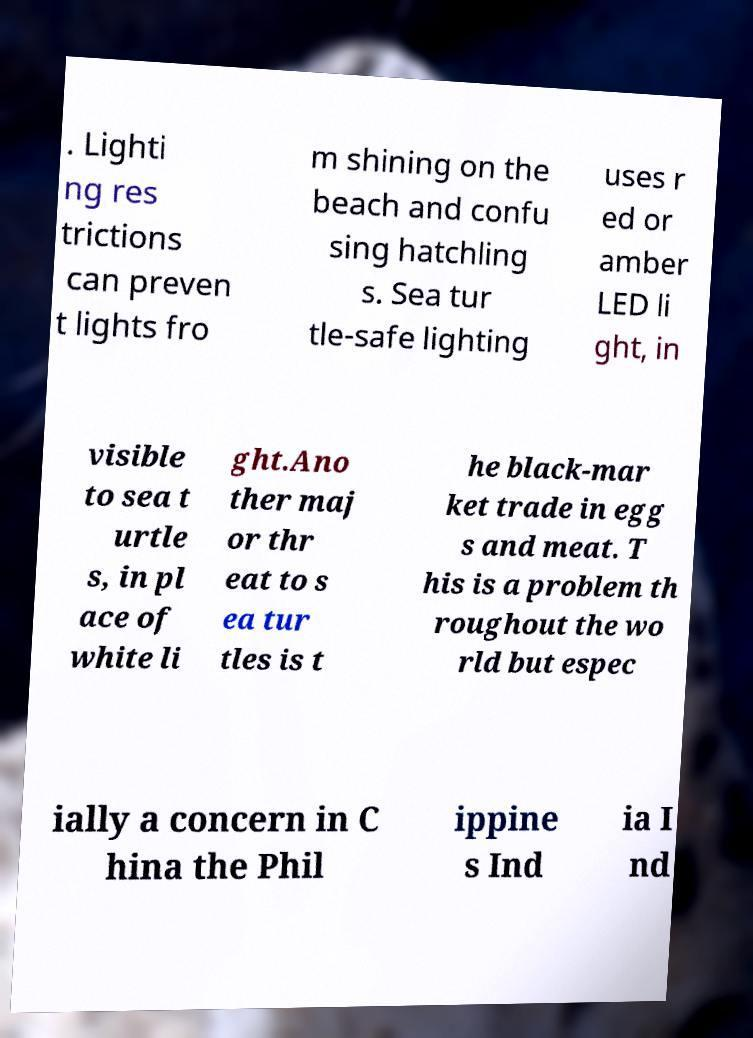Please read and relay the text visible in this image. What does it say? . Lighti ng res trictions can preven t lights fro m shining on the beach and confu sing hatchling s. Sea tur tle-safe lighting uses r ed or amber LED li ght, in visible to sea t urtle s, in pl ace of white li ght.Ano ther maj or thr eat to s ea tur tles is t he black-mar ket trade in egg s and meat. T his is a problem th roughout the wo rld but espec ially a concern in C hina the Phil ippine s Ind ia I nd 